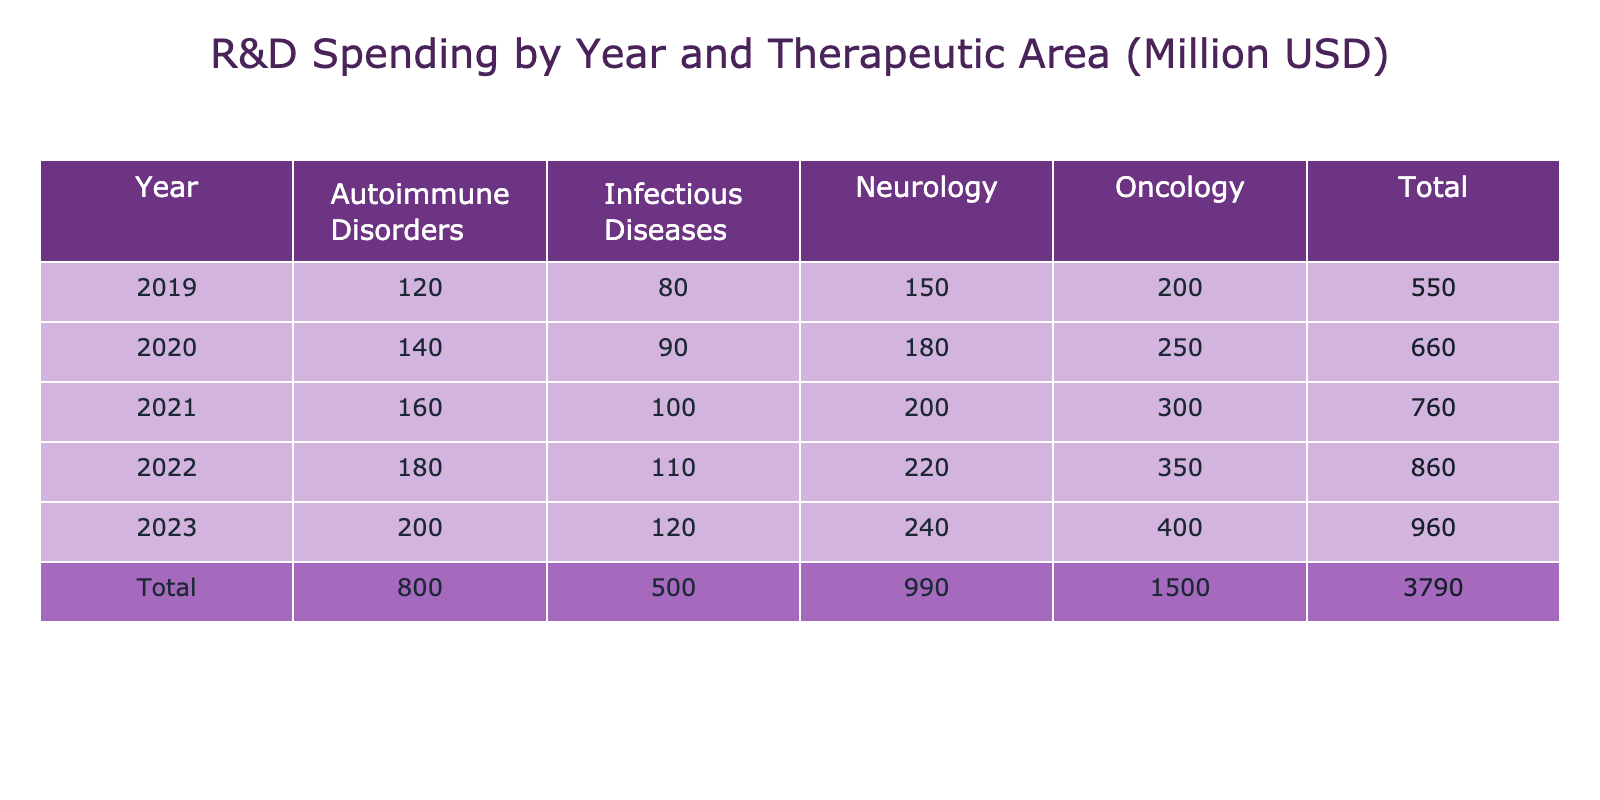What was the R&D spending in Oncology in 2021? In the table, under the column for Oncology and the row for 2021, the value is 300 million USD.
Answer: 300 million USD Which therapeutic area had the highest R&D spending in 2023? In 2023, Oncology had the highest value of 400 million USD, compared to other areas: Neurology (240), Autoimmune Disorders (200), and Infectious Diseases (120).
Answer: Oncology What was the total R&D spending for Autoimmune Disorders from 2019 to 2023? To calculate this, we sum the spending for Autoimmune Disorders over these years: (120 + 140 + 160 + 180 + 200) = 800 million USD.
Answer: 800 million USD Did R&D spending in Neurology increase every year from 2019 to 2023? The spending in Neurology was: 150 million USD in 2019, 180 million USD in 2020, 200 million USD in 2021, 220 million USD in 2022, and 240 million USD in 2023. Since all these values are increasing, the answer is yes.
Answer: Yes What was the average R&D spending in Infectious Diseases over the five years? First, we sum the spending: (80 + 90 + 100 + 110 + 120) = 500 million USD. Then divide by the number of years (5): 500 / 5 = 100 million USD.
Answer: 100 million USD Which year saw the lowest total R&D spending across all therapeutic areas? By inspecting the Total row, we see that the year with the lowest total is 2019 with 550 million USD compared to other years: 660 million USD (2020), 760 million USD (2021), 900 million USD (2022), and 1080 million USD (2023).
Answer: 2019 What was the increase in R&D spending for Oncology from 2020 to 2023? In 2020, R&D spending for Oncology was 250 million USD and in 2023 it was 400 million USD. The increase is calculated as: 400 - 250 = 150 million USD.
Answer: 150 million USD Is it true that R&D spending across all years is higher in 2023 compared to 2019? The total for 2019 is 550 million USD, and for 2023, the total is 1080 million USD. Since 1080 is greater than 550, the statement is true.
Answer: Yes 